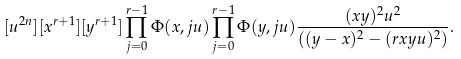<formula> <loc_0><loc_0><loc_500><loc_500>[ u ^ { 2 n } ] [ x ^ { r + 1 } ] [ y ^ { r + 1 } ] \prod _ { j = 0 } ^ { r - 1 } \Phi ( x , j u ) \prod _ { j = 0 } ^ { r - 1 } \Phi ( y , j u ) \frac { ( x y ) ^ { 2 } u ^ { 2 } } { ( ( y - x ) ^ { 2 } - ( r x y u ) ^ { 2 } ) } .</formula> 